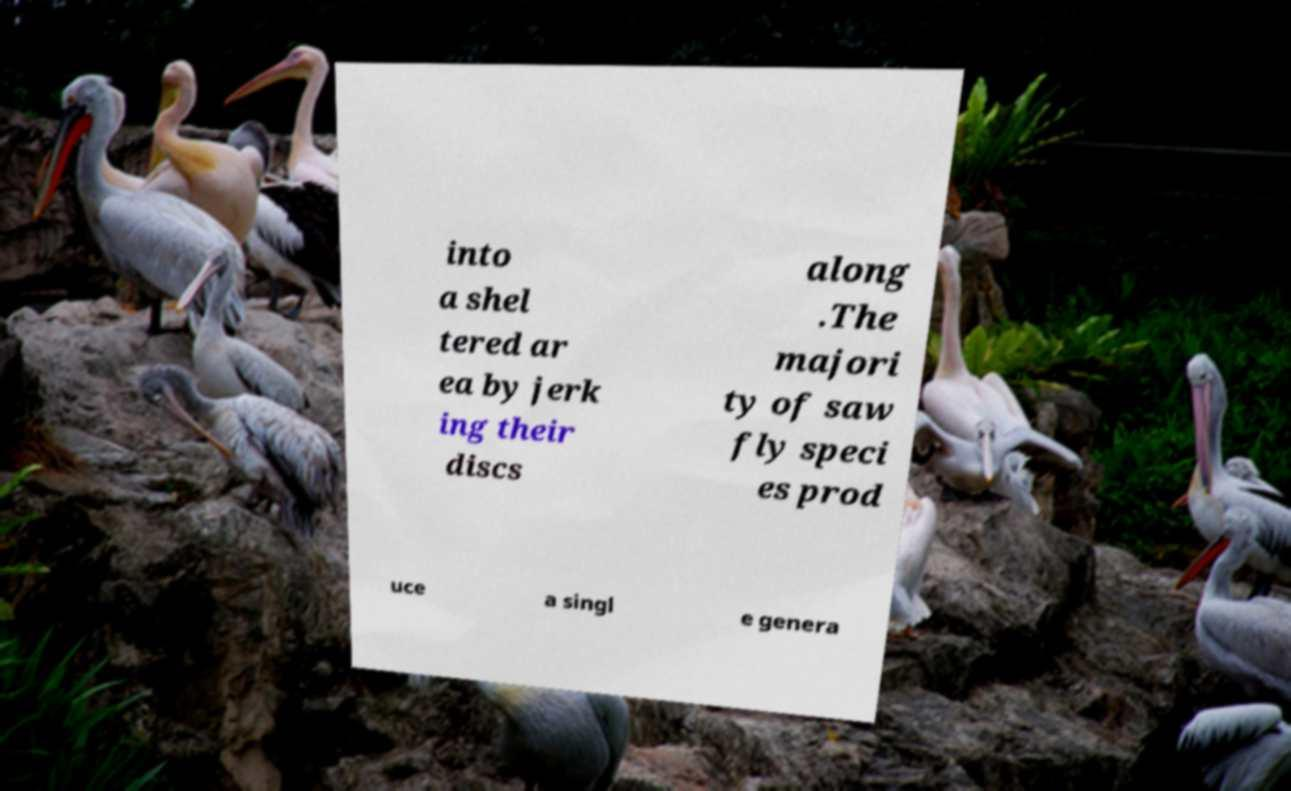Please identify and transcribe the text found in this image. into a shel tered ar ea by jerk ing their discs along .The majori ty of saw fly speci es prod uce a singl e genera 